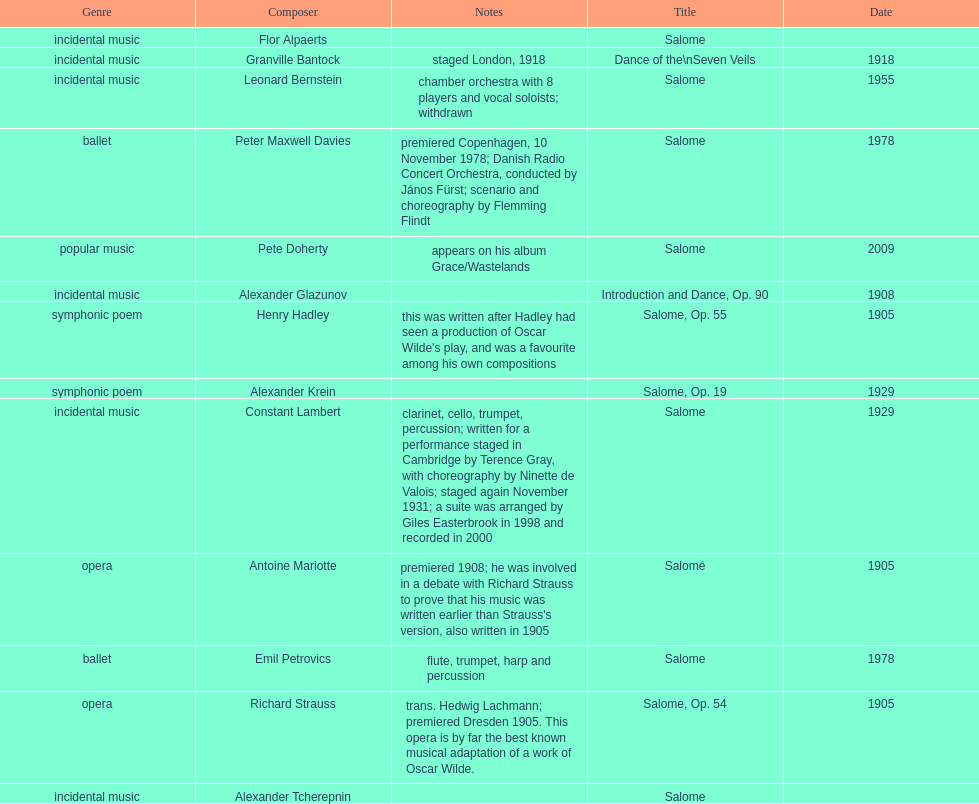Which composer published first granville bantock or emil petrovics? Granville Bantock. 